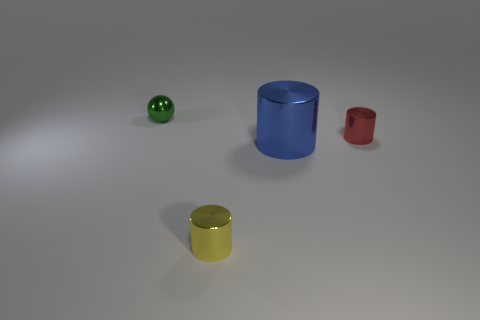Add 4 metallic cylinders. How many objects exist? 8 Subtract all spheres. How many objects are left? 3 Add 4 red cylinders. How many red cylinders are left? 5 Add 2 large brown cylinders. How many large brown cylinders exist? 2 Subtract 0 gray blocks. How many objects are left? 4 Subtract all large blue things. Subtract all yellow blocks. How many objects are left? 3 